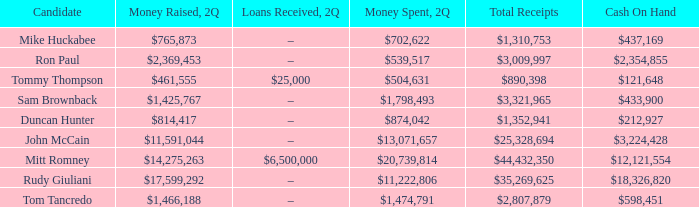Name the money raised when 2Q has money spent and 2Q is $874,042 $814,417. 